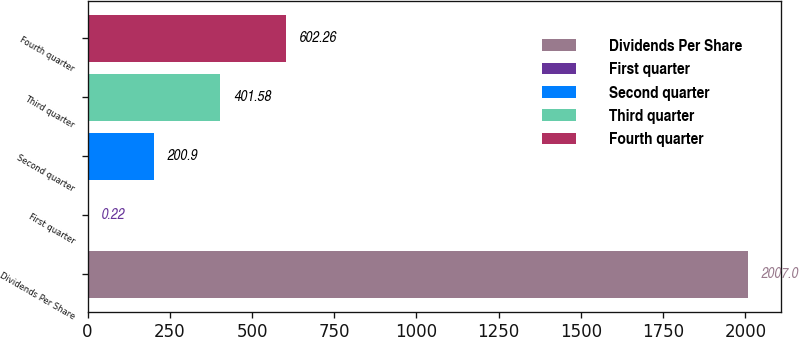Convert chart. <chart><loc_0><loc_0><loc_500><loc_500><bar_chart><fcel>Dividends Per Share<fcel>First quarter<fcel>Second quarter<fcel>Third quarter<fcel>Fourth quarter<nl><fcel>2007<fcel>0.22<fcel>200.9<fcel>401.58<fcel>602.26<nl></chart> 